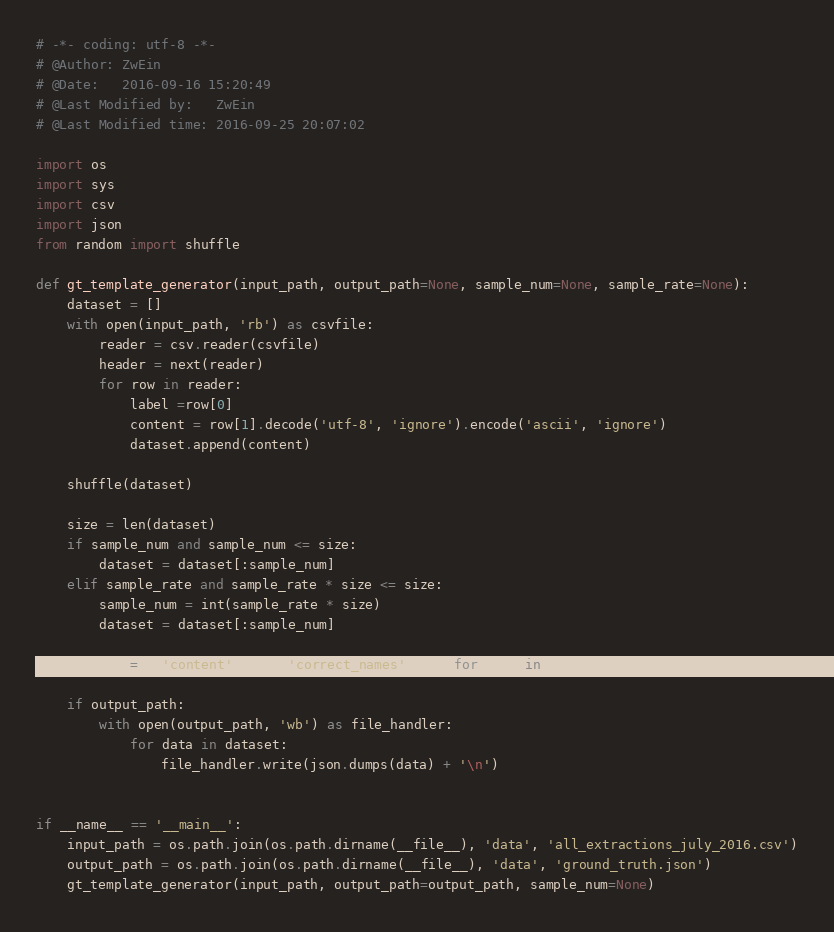Convert code to text. <code><loc_0><loc_0><loc_500><loc_500><_Python_># -*- coding: utf-8 -*-
# @Author: ZwEin
# @Date:   2016-09-16 15:20:49
# @Last Modified by:   ZwEin
# @Last Modified time: 2016-09-25 20:07:02

import os
import sys
import csv
import json
from random import shuffle

def gt_template_generator(input_path, output_path=None, sample_num=None, sample_rate=None):
    dataset = []
    with open(input_path, 'rb') as csvfile:
        reader = csv.reader(csvfile)
        header = next(reader)
        for row in reader:
            label =row[0]
            content = row[1].decode('utf-8', 'ignore').encode('ascii', 'ignore')
            dataset.append(content)

    shuffle(dataset)

    size = len(dataset)
    if sample_num and sample_num <= size:
        dataset = dataset[:sample_num]
    elif sample_rate and sample_rate * size <= size:
        sample_num = int(sample_rate * size)
        dataset = dataset[:sample_num]

    dataset = [{'content':data, 'correct_names': []} for data in dataset]

    if output_path:
        with open(output_path, 'wb') as file_handler:
            for data in dataset:
                file_handler.write(json.dumps(data) + '\n')


if __name__ == '__main__':
    input_path = os.path.join(os.path.dirname(__file__), 'data', 'all_extractions_july_2016.csv')
    output_path = os.path.join(os.path.dirname(__file__), 'data', 'ground_truth.json')
    gt_template_generator(input_path, output_path=output_path, sample_num=None)
</code> 